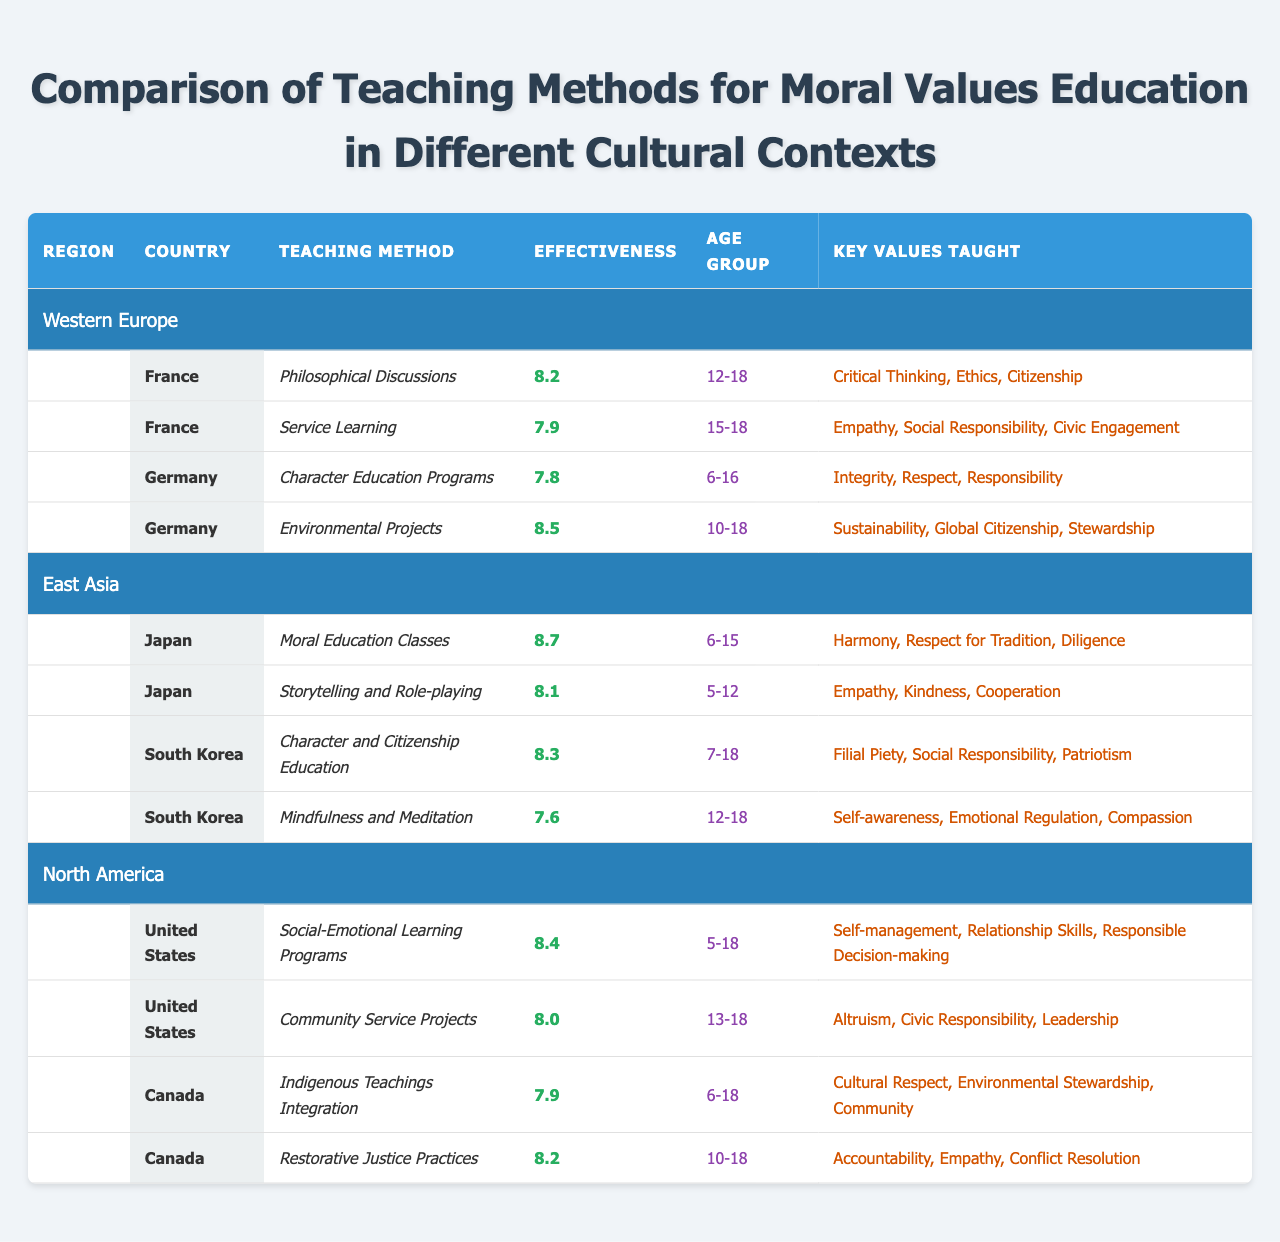What is the teaching method with the highest effectiveness in Japan? The effectiveness of teaching methods in Japan are listed, and "Moral Education Classes" has an effectiveness rating of 8.7, which is the highest among all methods in Japan.
Answer: Moral Education Classes Which country in Western Europe uses "Service Learning" as a teaching method? The table lists "Service Learning" under France in Western Europe, indicating that it is the specific country using this method.
Answer: France What are the key values taught in South Korea's "Mindfulness and Meditation" method? The table shows that the key values taught in the "Mindfulness and Meditation" method in South Korea are "Self-awareness," "Emotional Regulation," and "Compassion."
Answer: Self-awareness, Emotional Regulation, Compassion What is the average effectiveness of teaching methods in North America? The effectiveness ratings for North America are 8.4 and 8.0. Adding these gives 16.4, and dividing by 2 (the number of methods) gives an average of 8.2.
Answer: 8.2 Which region has the lowest effectiveness rating for any teaching method? By reviewing the effectiveness ratings, Germany's "Character Education Programs" has the lowest rating at 7.8 among all listed methods, making it the lowest for the regions.
Answer: 7.8 Is "Environmental Projects" more effective than "Service Learning" in France? Comparing the effectiveness, "Environmental Projects" from Germany has a score of 8.5 while "Service Learning" from France has 7.9, making the former more effective.
Answer: Yes Identify the teaching method in Canada that emphasizes "Community." The table shows that "Indigenous Teachings Integration" in Canada emphasizes "Community" as one of its key values taught.
Answer: Indigenous Teachings Integration How many total teaching methods have an effectiveness rating above 8.0? By checking the effectiveness ratings in the table, we find that out of the methods listed, four have a rating above 8.0: "Moral Education Classes," "Environmental Projects," "Social-Emotional Learning Programs," and "Restorative Justice Practices." Thus, there are four total.
Answer: 4 What is the key value taught in both Germany and South Korea? The table lists "Social Responsibility" as a key value taught in both Germany's "Environmental Projects" and South Korea's "Character and Citizenship Education."
Answer: Social Responsibility What age group is targeted by the "Community Service Projects" in the United States? According to the table, "Community Service Projects" targets the age group of "13-18" years in the United States.
Answer: 13-18 